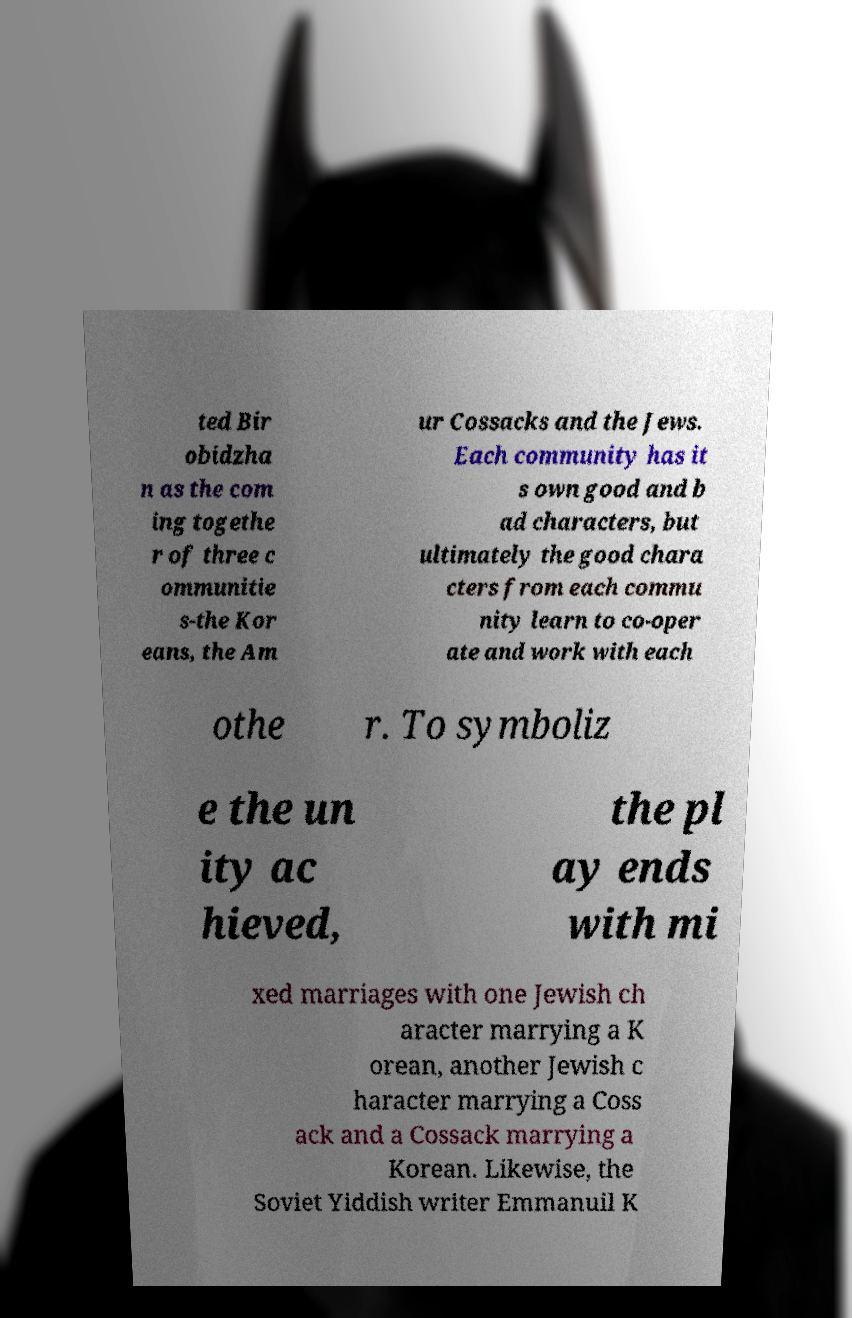For documentation purposes, I need the text within this image transcribed. Could you provide that? ted Bir obidzha n as the com ing togethe r of three c ommunitie s-the Kor eans, the Am ur Cossacks and the Jews. Each community has it s own good and b ad characters, but ultimately the good chara cters from each commu nity learn to co-oper ate and work with each othe r. To symboliz e the un ity ac hieved, the pl ay ends with mi xed marriages with one Jewish ch aracter marrying a K orean, another Jewish c haracter marrying a Coss ack and a Cossack marrying a Korean. Likewise, the Soviet Yiddish writer Emmanuil K 